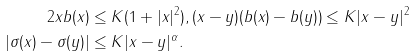Convert formula to latex. <formula><loc_0><loc_0><loc_500><loc_500>2 x b ( x ) & \leq K ( 1 + | x | ^ { 2 } ) , ( x - y ) ( b ( x ) - b ( y ) ) \leq K | x - y | ^ { 2 } \\ | \sigma ( x ) - \sigma ( y ) | & \leq K | x - y | ^ { \alpha } .</formula> 